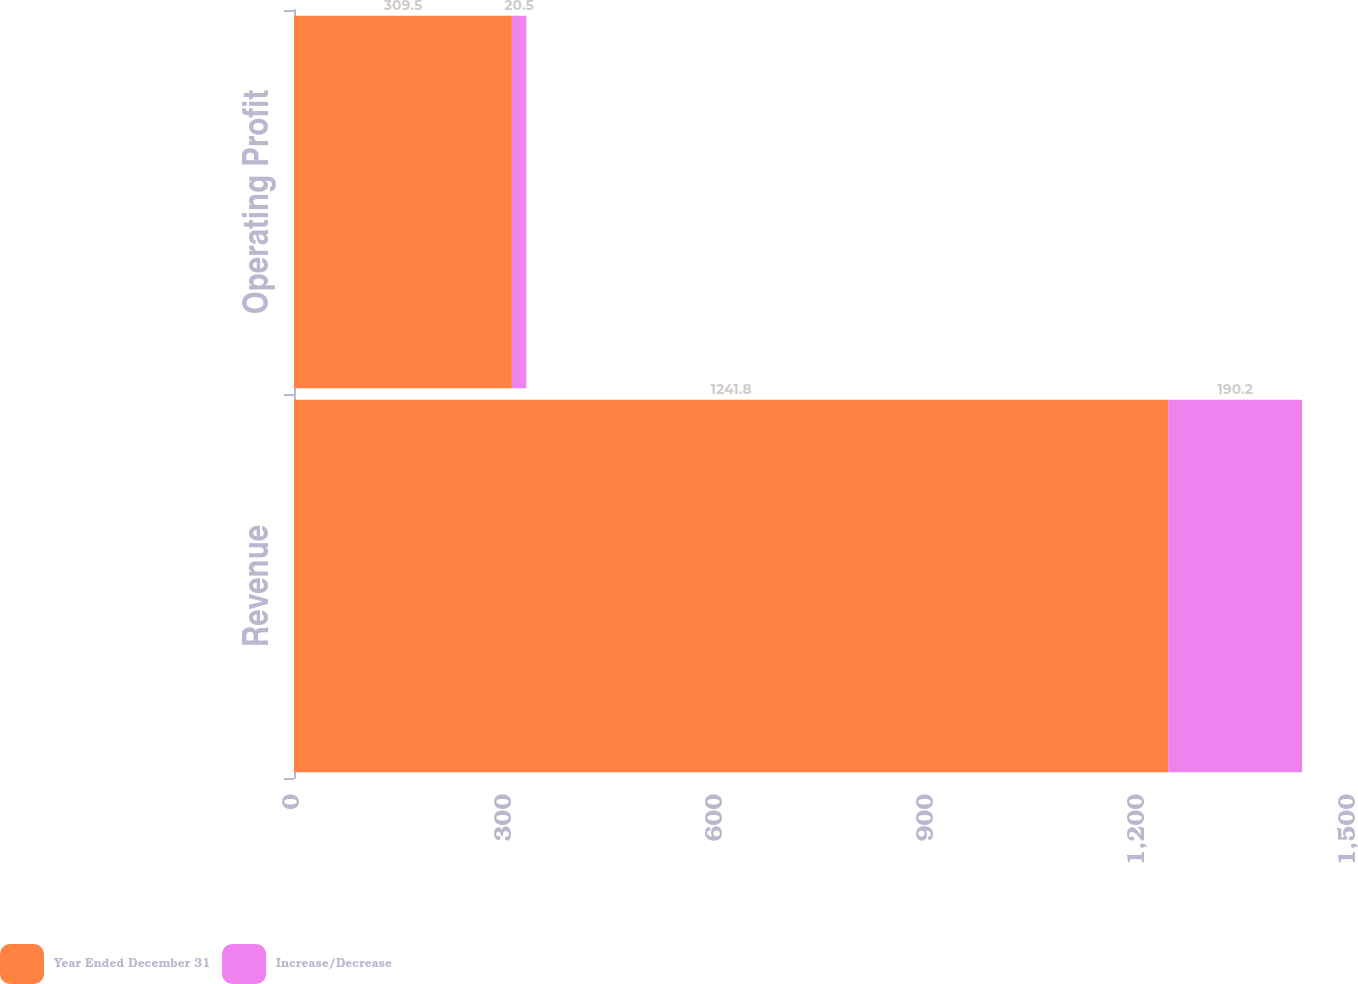<chart> <loc_0><loc_0><loc_500><loc_500><stacked_bar_chart><ecel><fcel>Revenue<fcel>Operating Profit<nl><fcel>Year Ended December 31<fcel>1241.8<fcel>309.5<nl><fcel>Increase/Decrease<fcel>190.2<fcel>20.5<nl></chart> 